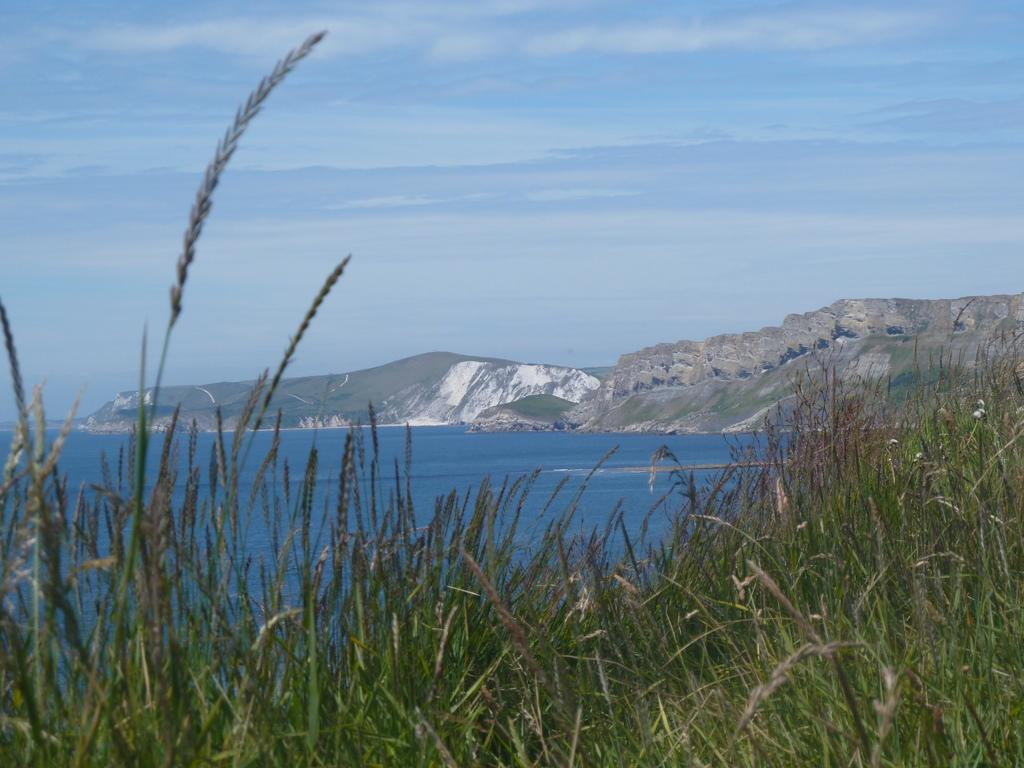What type of natural environment is depicted in the image? The image features a sea, plants, and mountains. Can you describe the plants in the image? There are many plants visible in the image. What type of geographical feature can be seen in the distance? There are mountains in the image. What type of organization is responsible for the map in the image? There is no map present in the image, so it is not possible to determine which organization might be responsible for it. 